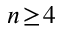<formula> <loc_0><loc_0><loc_500><loc_500>n \, \geq \, 4</formula> 